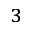<formula> <loc_0><loc_0><loc_500><loc_500>^ { 3 }</formula> 